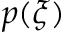<formula> <loc_0><loc_0><loc_500><loc_500>p ( \xi )</formula> 